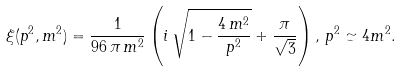Convert formula to latex. <formula><loc_0><loc_0><loc_500><loc_500>\xi ( p ^ { 2 } , m ^ { 2 } ) = \frac { 1 } { 9 6 \, \pi \, m ^ { 2 } } \left ( i \, \sqrt { 1 - \frac { 4 \, m ^ { 2 } } { p ^ { 2 } } } + \frac { \pi } { \sqrt { 3 } } \right ) , \, p ^ { 2 } \simeq 4 m ^ { 2 } .</formula> 